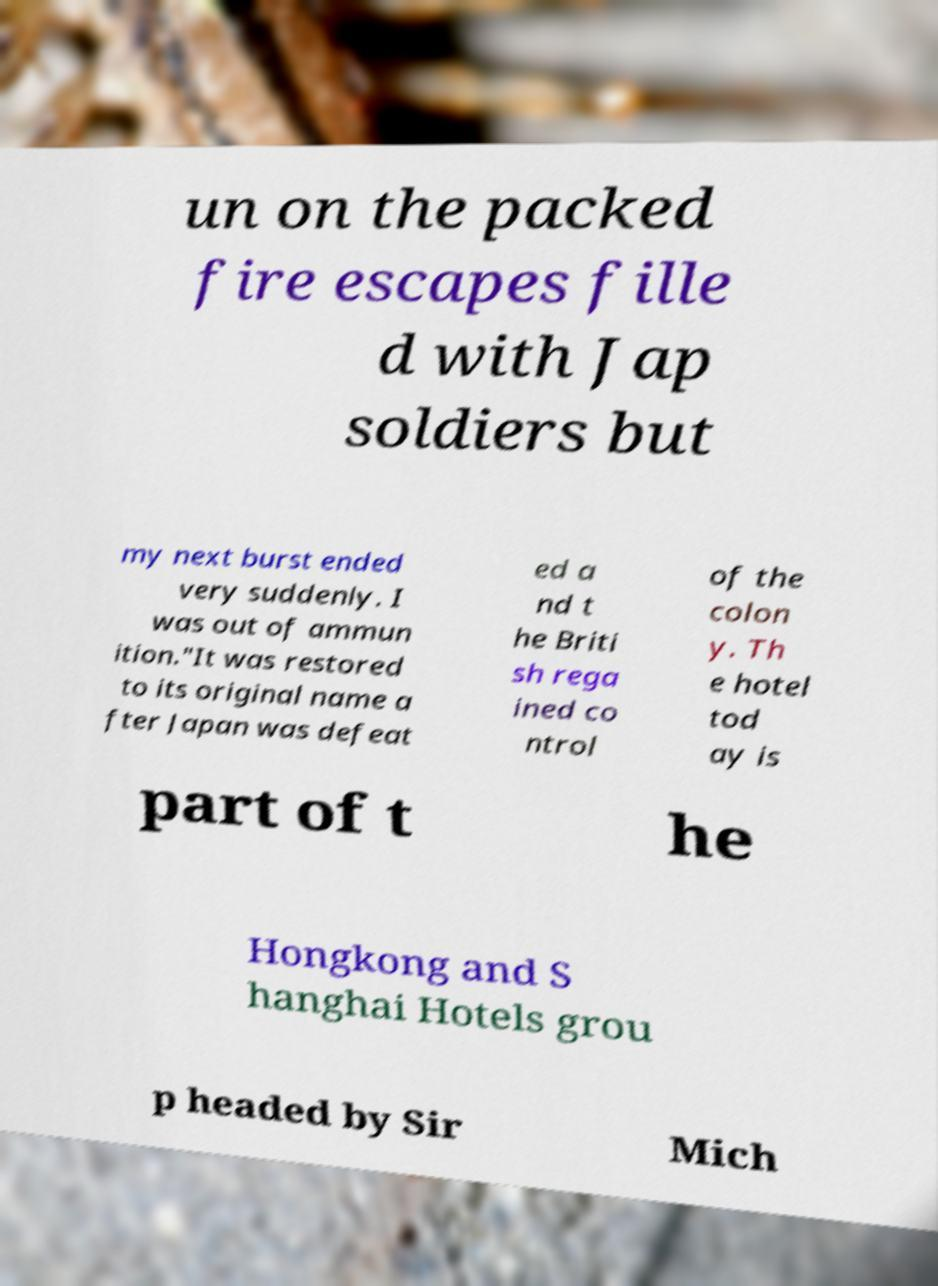Please identify and transcribe the text found in this image. un on the packed fire escapes fille d with Jap soldiers but my next burst ended very suddenly. I was out of ammun ition."It was restored to its original name a fter Japan was defeat ed a nd t he Briti sh rega ined co ntrol of the colon y. Th e hotel tod ay is part of t he Hongkong and S hanghai Hotels grou p headed by Sir Mich 